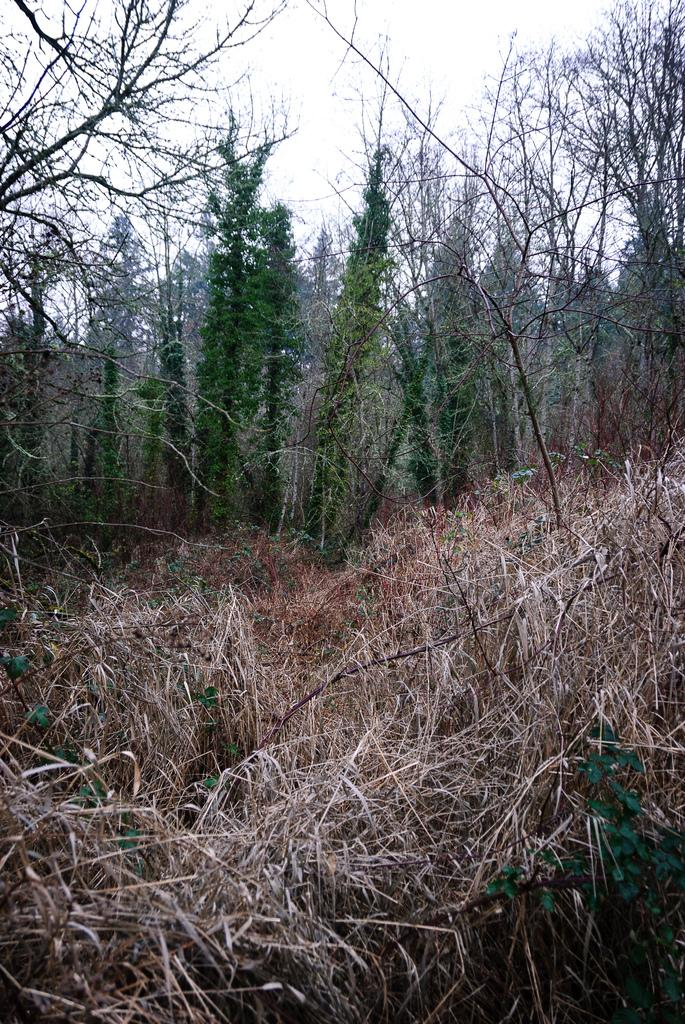What type of vegetation can be seen on the ground in the image? There are dried plants on the ground in the image. What can be seen in the background of the image? There are trees and the sky visible in the background of the image. Reasoning: Let' Let's think step by step in order to produce the conversation. We start by identifying the main subject on the ground, which is the dried plants. Then, we expand the conversation to include the background, mentioning the trees and the sky. Each question is designed to elicit a specific detail about the image that is known from the provided facts. Absurd Question/Answer: Where is the line of fairies in the image? There is no line of fairies present in the image. What type of brake can be seen on the trees in the image? There are no brakes visible on the trees in the image. Where is the line of fairies in the image? There is no line of fairies present in the image. What type of brake can be seen on the trees in the image? There are no brakes visible on the trees in the image. 